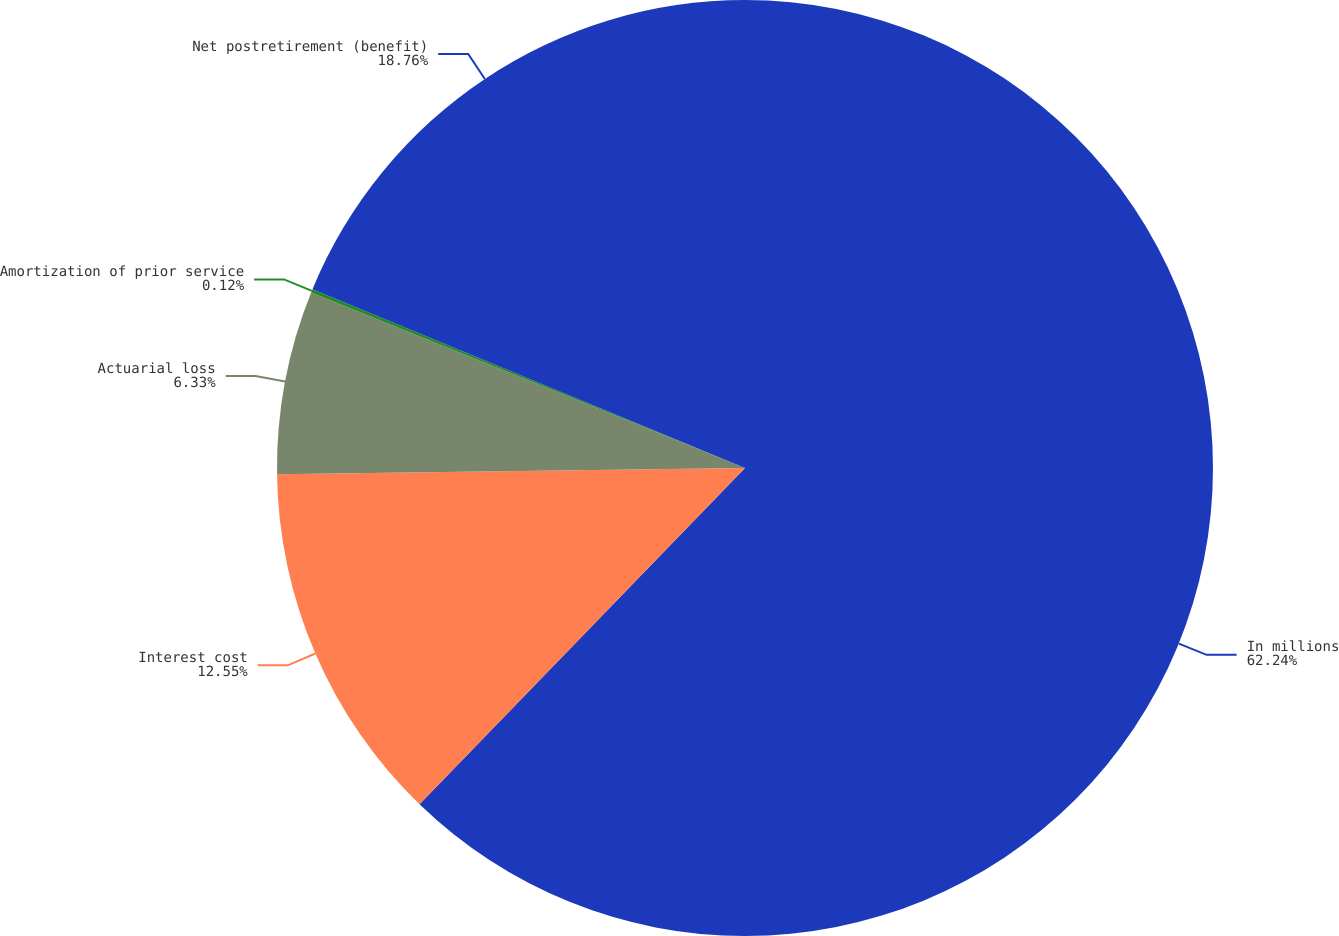<chart> <loc_0><loc_0><loc_500><loc_500><pie_chart><fcel>In millions<fcel>Interest cost<fcel>Actuarial loss<fcel>Amortization of prior service<fcel>Net postretirement (benefit)<nl><fcel>62.24%<fcel>12.55%<fcel>6.33%<fcel>0.12%<fcel>18.76%<nl></chart> 